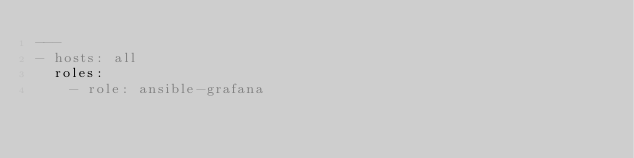Convert code to text. <code><loc_0><loc_0><loc_500><loc_500><_YAML_>---
- hosts: all
  roles:
    - role: ansible-grafana
</code> 